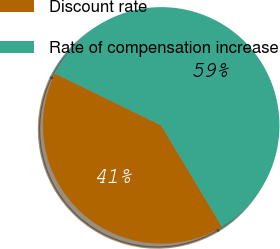Convert chart to OTSL. <chart><loc_0><loc_0><loc_500><loc_500><pie_chart><fcel>Discount rate<fcel>Rate of compensation increase<nl><fcel>40.83%<fcel>59.17%<nl></chart> 